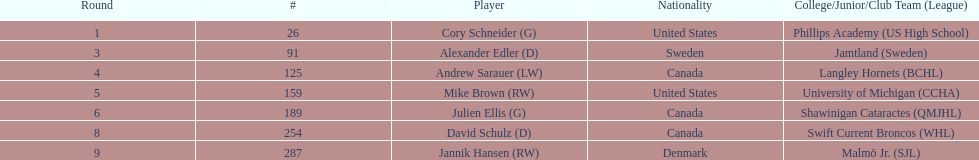For how many players is canada their listed nationality? 3. 